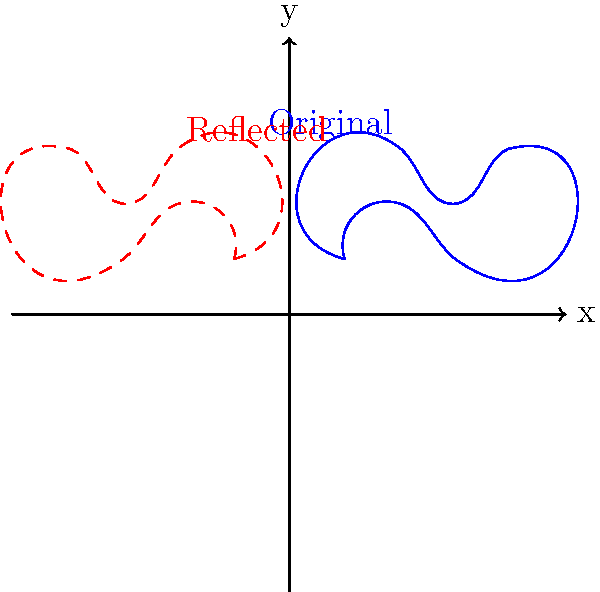In your latest crime novel, a crucial piece of evidence is a fingerprint found at the crime scene. To determine if the fingerprint has bilateral symmetry, you need to reflect it across the y-axis. Given the fingerprint pattern shown in blue, which of the following statements is true about its reflection across the y-axis (shown in red)?

A) The reflected pattern is identical to the original, indicating perfect bilateral symmetry.
B) The reflected pattern is a mirror image of the original, but not identical, suggesting the fingerprint lacks perfect bilateral symmetry.
C) The reflected pattern is completely different from the original, implying no symmetry at all.
D) The reflection process has distorted the fingerprint, making it impossible to determine symmetry. To analyze the symmetry of the fingerprint pattern, we need to follow these steps:

1) First, observe the original fingerprint pattern (blue) and its reflection across the y-axis (red dashed line).

2) In a perfectly symmetrical pattern, the original and reflected images would be identical when folded along the y-axis.

3) Compare key points of the original and reflected patterns:
   - The leftmost point of the original (1,1) is reflected to (-1,1)
   - The highest point (2,3) is reflected to (-2,3)
   - The rightmost point (4,3) is reflected to (-4,3)

4) Notice that while the general shape is similar, there are differences:
   - The curves don't align perfectly
   - The loops and whorls are not exactly the same on both sides

5) This indicates that while the fingerprint has a similar overall shape when reflected, it's not perfectly symmetrical.

6) In the context of fingerprint analysis, this lack of perfect symmetry is expected, as natural fingerprints rarely have perfect bilateral symmetry.

Therefore, the correct answer is B. The reflected pattern is a mirror image of the original, but not identical, suggesting the fingerprint lacks perfect bilateral symmetry.
Answer: B 